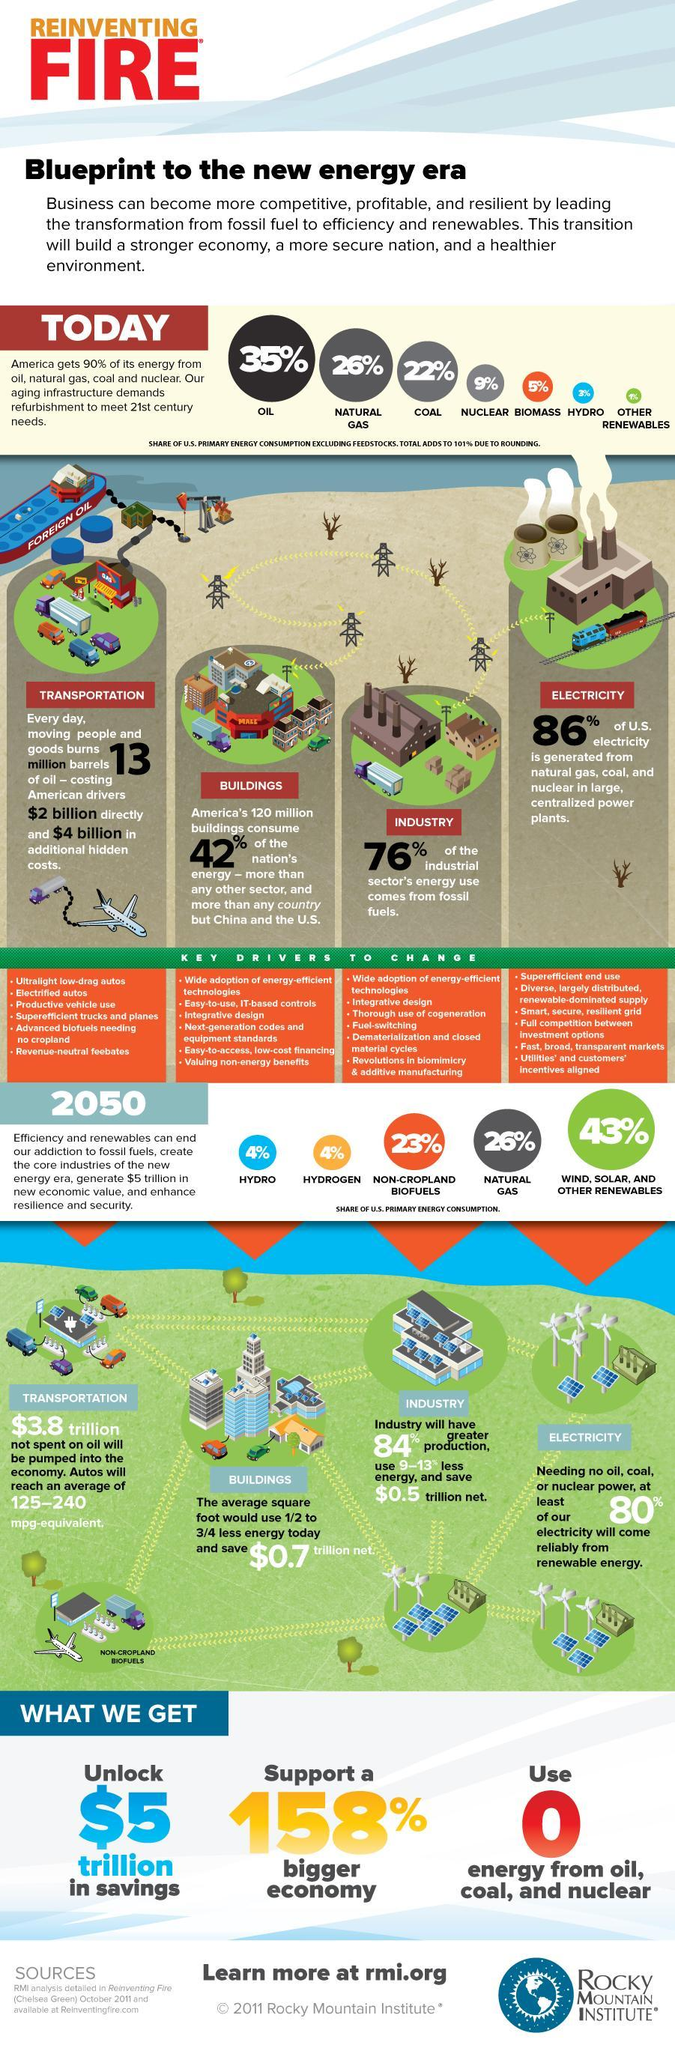What percent of energy in America comes from oil and natural gas?
Answer the question with a short phrase. 61% What percent of US primary fuel consumption is from non-cropland biofuels and natural gas? 49% 